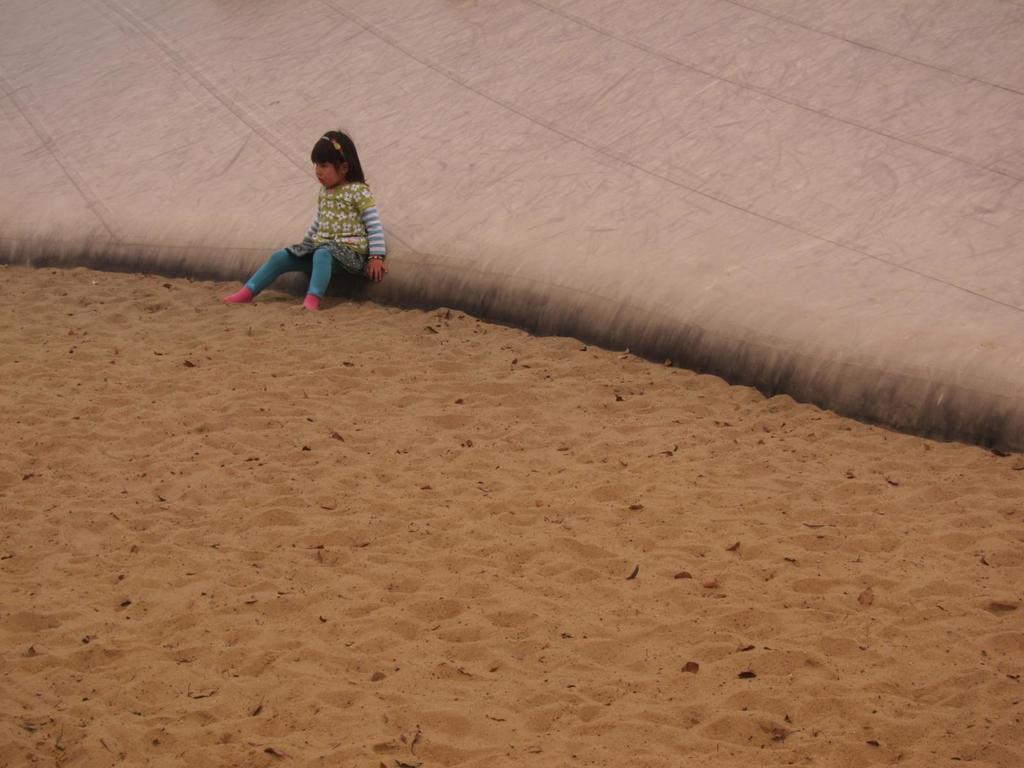How would you summarize this image in a sentence or two? In the picture we can see a child wearing dress is sitting on the white color surface. Here we can see the sand. 